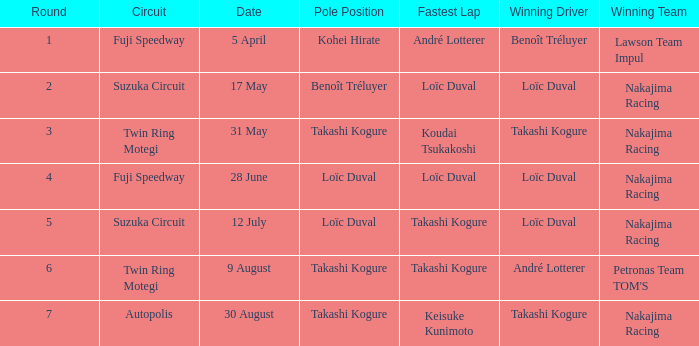What was the earlier round where Takashi Kogure got the fastest lap? 5.0. 